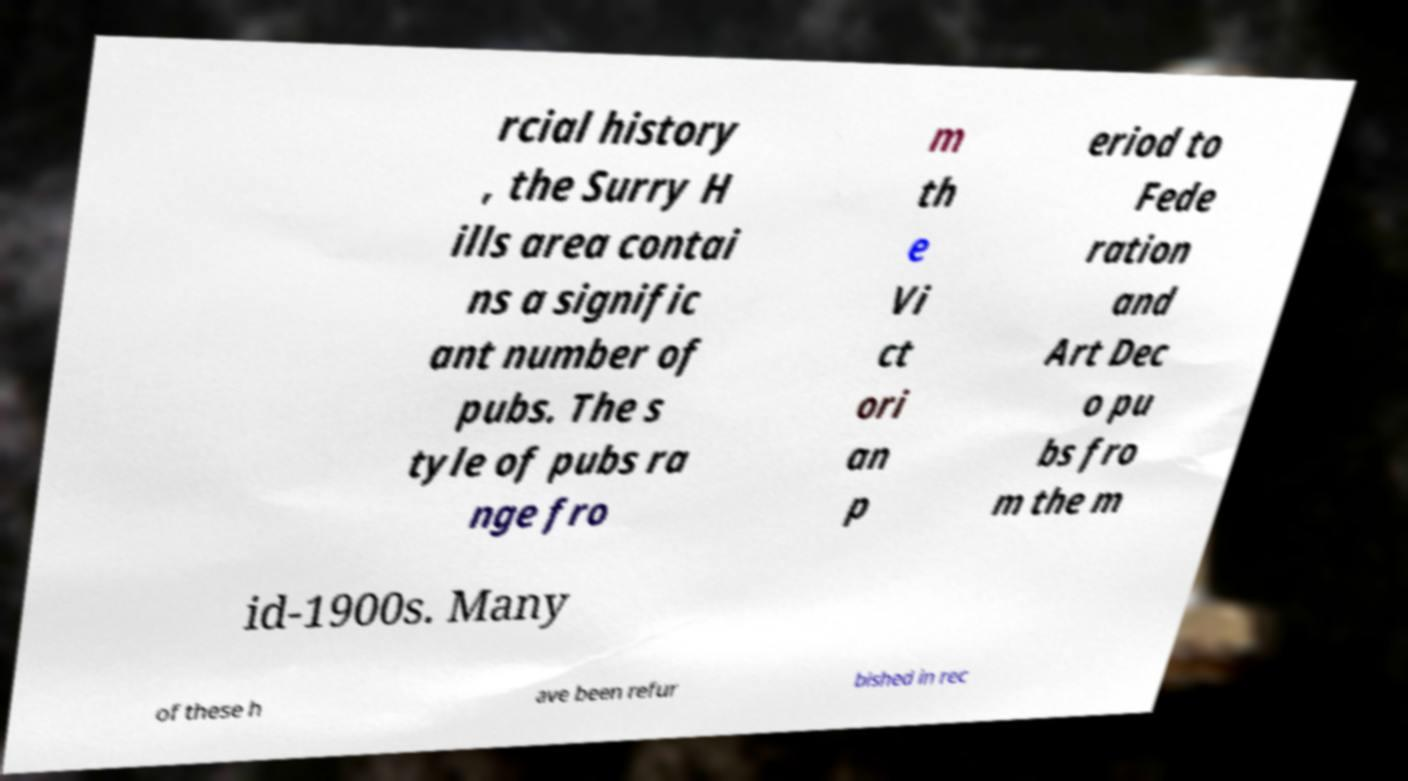Could you extract and type out the text from this image? rcial history , the Surry H ills area contai ns a signific ant number of pubs. The s tyle of pubs ra nge fro m th e Vi ct ori an p eriod to Fede ration and Art Dec o pu bs fro m the m id-1900s. Many of these h ave been refur bished in rec 